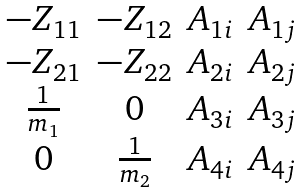<formula> <loc_0><loc_0><loc_500><loc_500>\begin{matrix} - Z _ { 1 1 } & - Z _ { 1 2 } & A _ { 1 i } & A _ { 1 j } \\ - Z _ { 2 1 } & - Z _ { 2 2 } & A _ { 2 i } & A _ { 2 j } \\ \frac { 1 } { m _ { 1 } } & 0 & A _ { 3 i } & A _ { 3 j } \\ 0 & \frac { 1 } { m _ { 2 } } & A _ { 4 i } & A _ { 4 j } \end{matrix}</formula> 